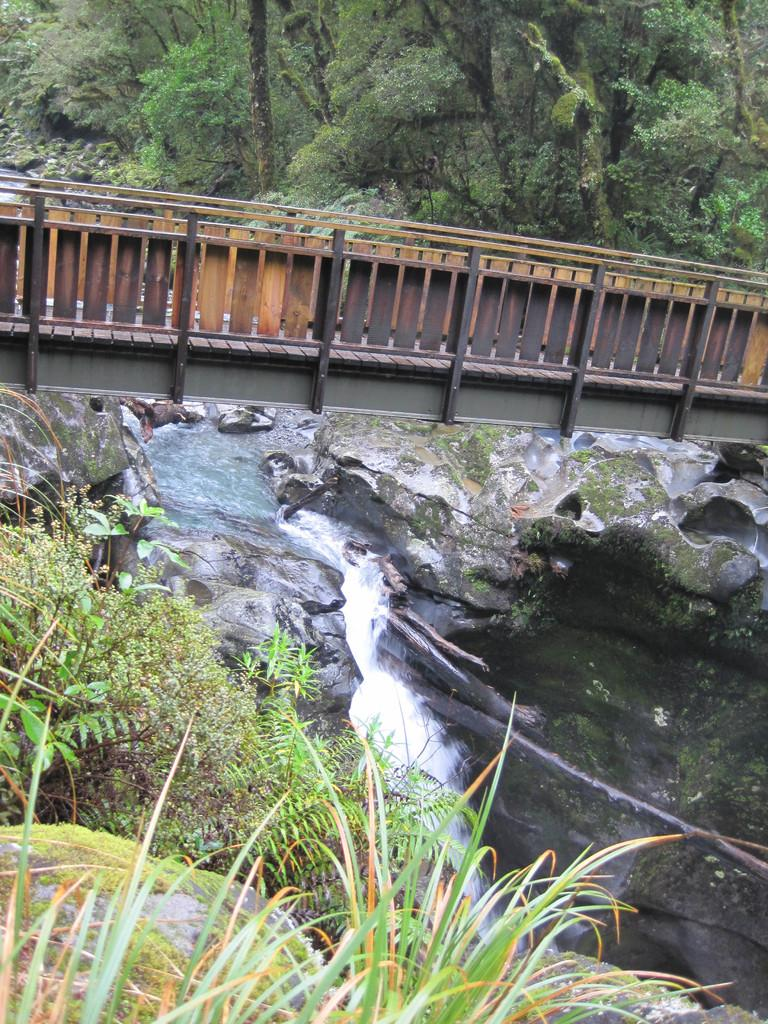What type of structure can be seen in the image? There is a bridge in the image. What natural feature is present in the image? There is a rock hill in the image. What can be seen flowing or covering the ground in the image? There is water visible in the image. What type of vegetation is present in the image? There is grass, plants, and trees in the image. Can you see a crow wearing a sock in the image? No, there is no crow or sock present in the image. Is there any string visible in the image? No, there is no string present in the image. 